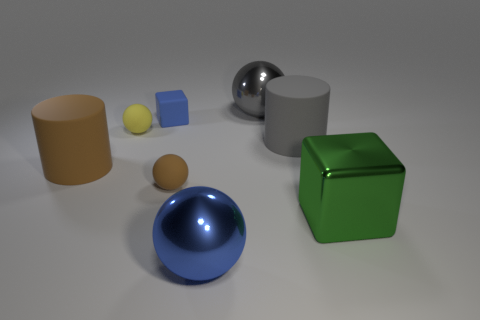What number of yellow objects are the same shape as the blue metal thing?
Keep it short and to the point. 1. Are there any objects that have the same color as the tiny matte cube?
Offer a very short reply. Yes. What number of things are either tiny rubber objects that are behind the brown rubber cylinder or big gray things to the left of the gray matte cylinder?
Provide a succinct answer. 3. Is there a large cylinder left of the blue thing to the right of the small blue rubber thing?
Your response must be concise. Yes. There is a blue thing that is the same size as the yellow sphere; what is its shape?
Provide a short and direct response. Cube. What number of things are tiny yellow spheres that are in front of the blue block or large red metallic spheres?
Your response must be concise. 1. How many other objects are there of the same material as the large green cube?
Provide a short and direct response. 2. What shape is the big thing that is the same color as the small block?
Offer a terse response. Sphere. How big is the block that is on the left side of the large green metal thing?
Offer a terse response. Small. There is a large gray object that is made of the same material as the large cube; what shape is it?
Provide a short and direct response. Sphere. 